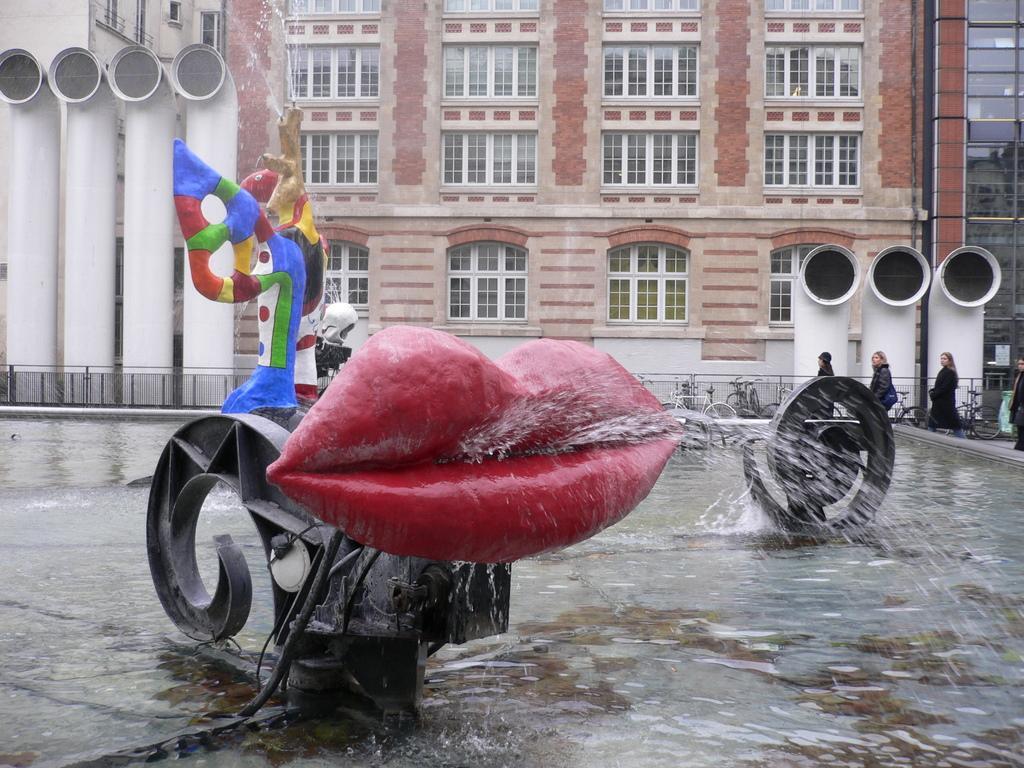In one or two sentences, can you explain what this image depicts? In this image we can see Stravinsky fountain, sculptures and spraying water sculptures and at the bottom we can see water. In the background there are buildings, windows, glass doors, fences, bicycles, pipes, few persons and windows. 